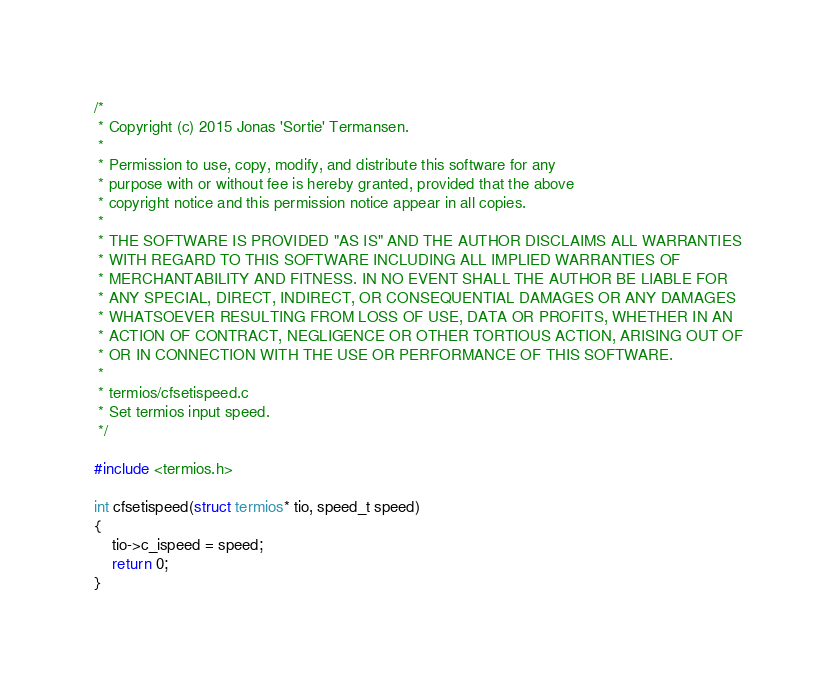Convert code to text. <code><loc_0><loc_0><loc_500><loc_500><_C_>/*
 * Copyright (c) 2015 Jonas 'Sortie' Termansen.
 *
 * Permission to use, copy, modify, and distribute this software for any
 * purpose with or without fee is hereby granted, provided that the above
 * copyright notice and this permission notice appear in all copies.
 *
 * THE SOFTWARE IS PROVIDED "AS IS" AND THE AUTHOR DISCLAIMS ALL WARRANTIES
 * WITH REGARD TO THIS SOFTWARE INCLUDING ALL IMPLIED WARRANTIES OF
 * MERCHANTABILITY AND FITNESS. IN NO EVENT SHALL THE AUTHOR BE LIABLE FOR
 * ANY SPECIAL, DIRECT, INDIRECT, OR CONSEQUENTIAL DAMAGES OR ANY DAMAGES
 * WHATSOEVER RESULTING FROM LOSS OF USE, DATA OR PROFITS, WHETHER IN AN
 * ACTION OF CONTRACT, NEGLIGENCE OR OTHER TORTIOUS ACTION, ARISING OUT OF
 * OR IN CONNECTION WITH THE USE OR PERFORMANCE OF THIS SOFTWARE.
 *
 * termios/cfsetispeed.c
 * Set termios input speed.
 */

#include <termios.h>

int cfsetispeed(struct termios* tio, speed_t speed)
{
	tio->c_ispeed = speed;
	return 0;
}
</code> 